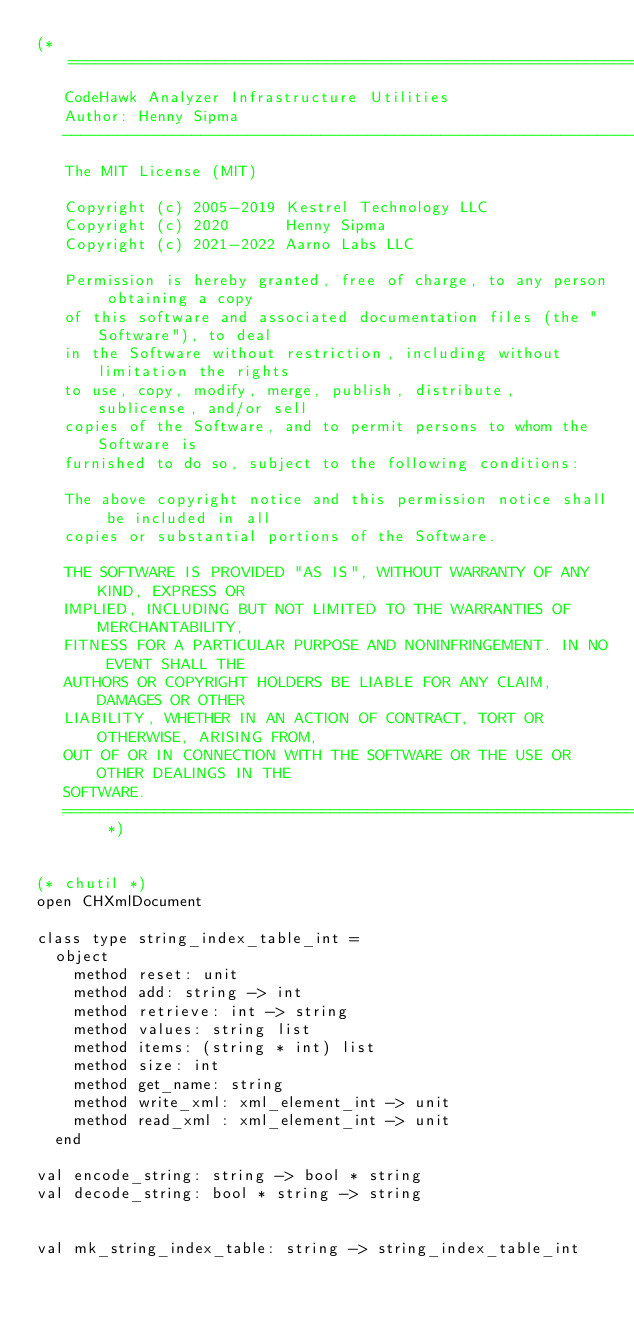Convert code to text. <code><loc_0><loc_0><loc_500><loc_500><_OCaml_>(* =============================================================================
   CodeHawk Analyzer Infrastructure Utilities
   Author: Henny Sipma
   ------------------------------------------------------------------------------
   The MIT License (MIT)
 
   Copyright (c) 2005-2019 Kestrel Technology LLC
   Copyright (c) 2020      Henny Sipma
   Copyright (c) 2021-2022 Aarno Labs LLC

   Permission is hereby granted, free of charge, to any person obtaining a copy
   of this software and associated documentation files (the "Software"), to deal
   in the Software without restriction, including without limitation the rights
   to use, copy, modify, merge, publish, distribute, sublicense, and/or sell
   copies of the Software, and to permit persons to whom the Software is
   furnished to do so, subject to the following conditions:
 
   The above copyright notice and this permission notice shall be included in all
   copies or substantial portions of the Software.
  
   THE SOFTWARE IS PROVIDED "AS IS", WITHOUT WARRANTY OF ANY KIND, EXPRESS OR
   IMPLIED, INCLUDING BUT NOT LIMITED TO THE WARRANTIES OF MERCHANTABILITY,
   FITNESS FOR A PARTICULAR PURPOSE AND NONINFRINGEMENT. IN NO EVENT SHALL THE
   AUTHORS OR COPYRIGHT HOLDERS BE LIABLE FOR ANY CLAIM, DAMAGES OR OTHER
   LIABILITY, WHETHER IN AN ACTION OF CONTRACT, TORT OR OTHERWISE, ARISING FROM,
   OUT OF OR IN CONNECTION WITH THE SOFTWARE OR THE USE OR OTHER DEALINGS IN THE
   SOFTWARE.
   ============================================================================= *)


(* chutil *)
open CHXmlDocument

class type string_index_table_int =
  object
    method reset: unit
    method add: string -> int
    method retrieve: int -> string
    method values: string list
    method items: (string * int) list
    method size: int
    method get_name: string
    method write_xml: xml_element_int -> unit
    method read_xml : xml_element_int -> unit
  end

val encode_string: string -> bool * string
val decode_string: bool * string -> string


val mk_string_index_table: string -> string_index_table_int
</code> 